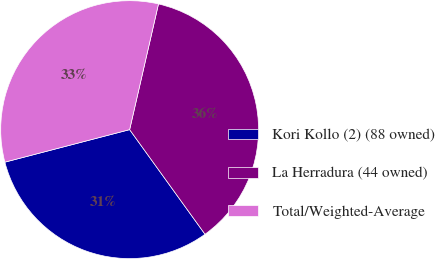<chart> <loc_0><loc_0><loc_500><loc_500><pie_chart><fcel>Kori Kollo (2) (88 owned)<fcel>La Herradura (44 owned)<fcel>Total/Weighted-Average<nl><fcel>30.88%<fcel>36.47%<fcel>32.65%<nl></chart> 